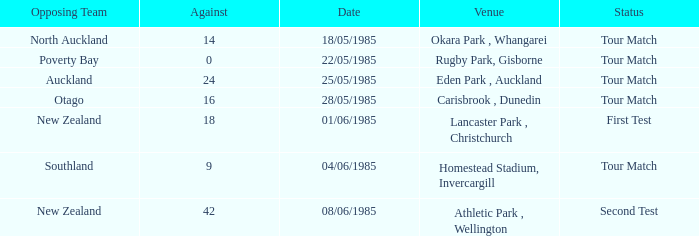What date was the opposing team Poverty Bay? 22/05/1985. 